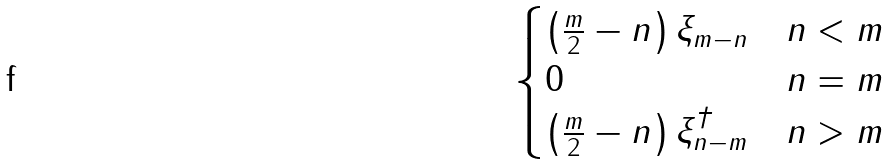<formula> <loc_0><loc_0><loc_500><loc_500>\begin{cases} \left ( \frac { m } { 2 } - n \right ) \xi _ { m - n } & n < m \\ 0 & n = m \\ \left ( \frac { m } { 2 } - n \right ) \xi _ { n - m } ^ { \dagger } & n > m \end{cases}</formula> 